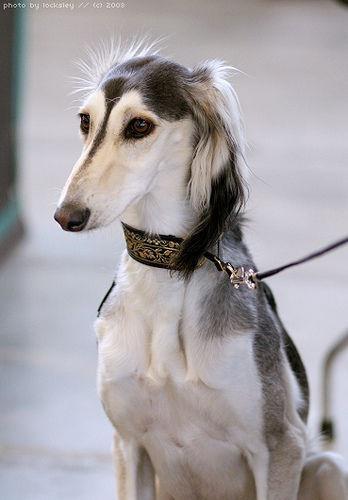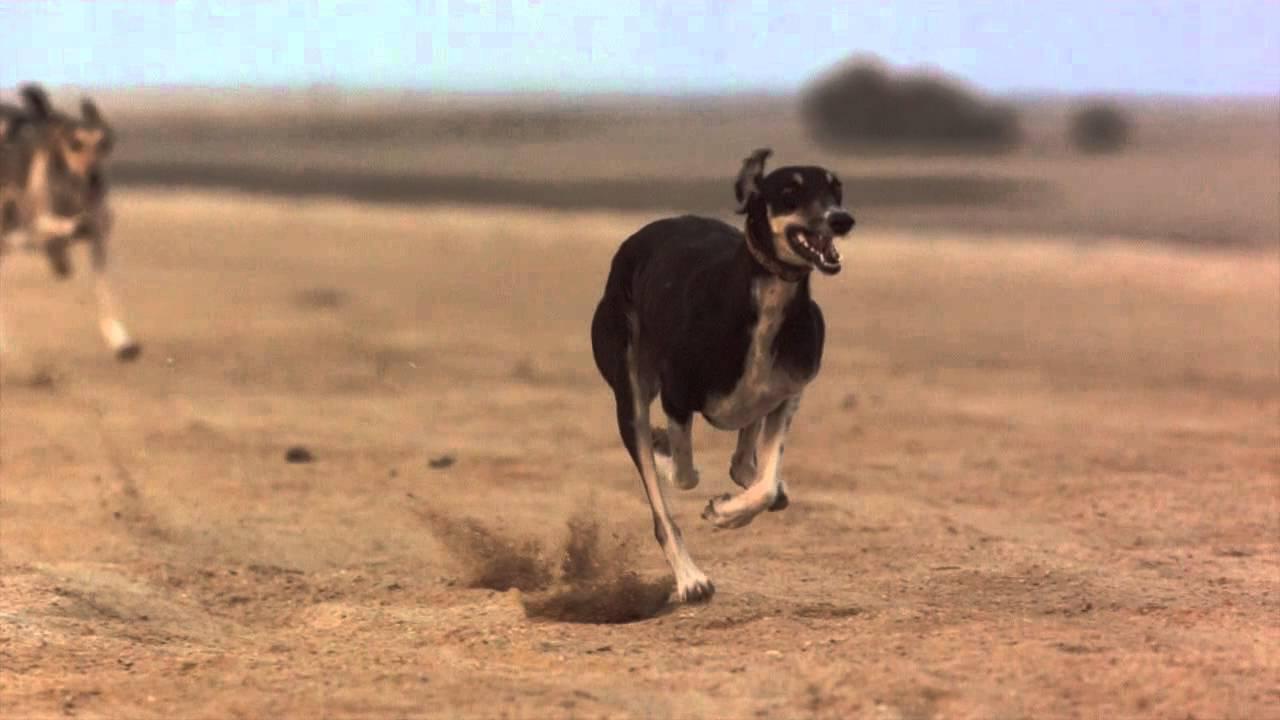The first image is the image on the left, the second image is the image on the right. Given the left and right images, does the statement "An image shows one hound running in front of another and kicking up clouds of dust." hold true? Answer yes or no. Yes. The first image is the image on the left, the second image is the image on the right. Given the left and right images, does the statement "One animal is on a leash." hold true? Answer yes or no. Yes. 